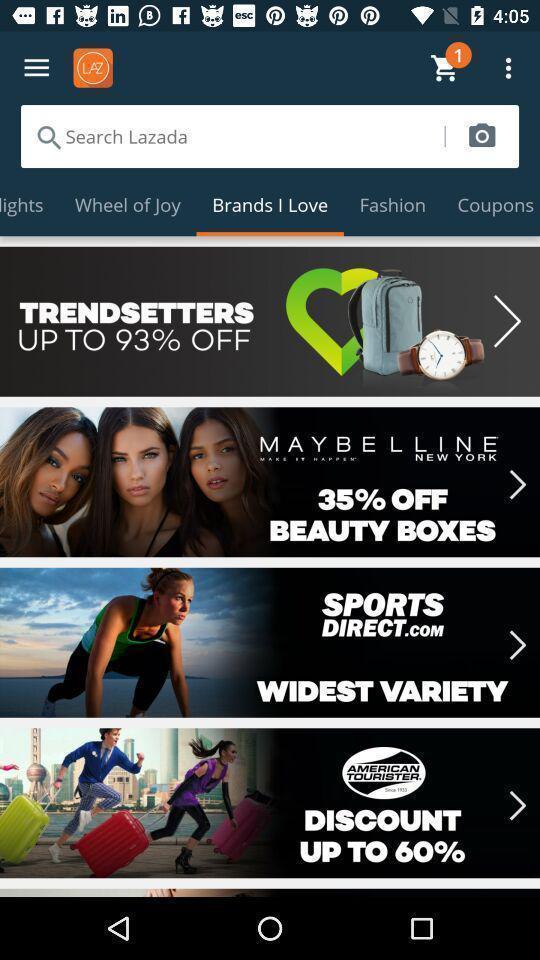Provide a description of this screenshot. Page showing the search bar along with multiple categories. 